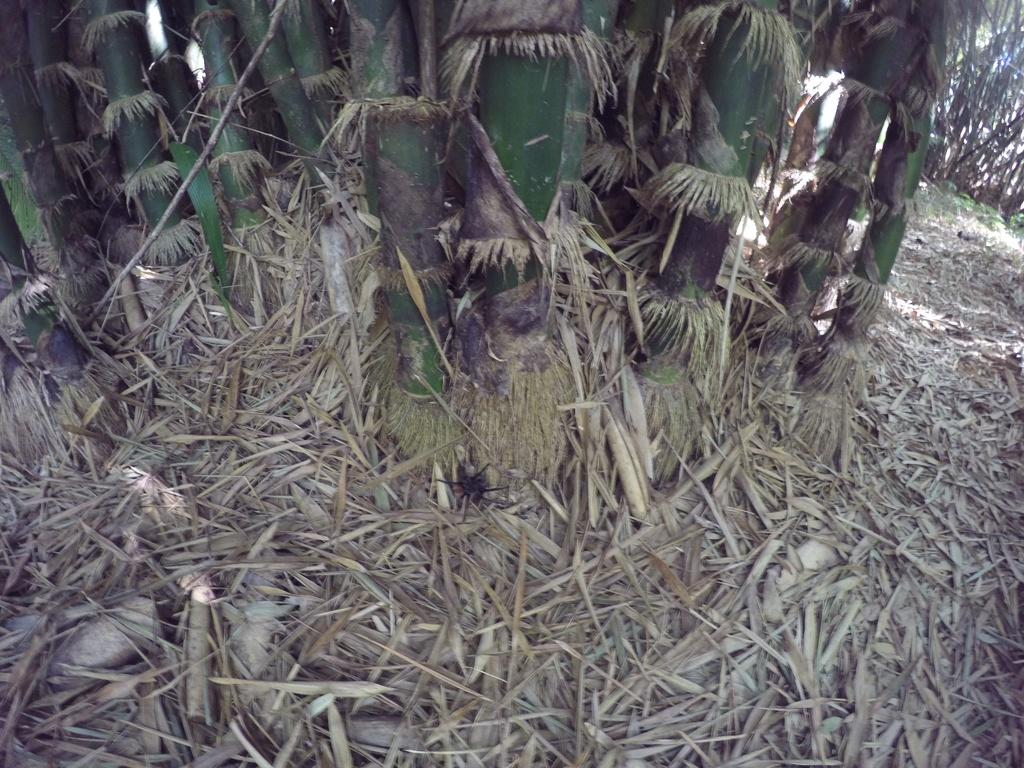What type of vegetation can be seen in the image? There are trees in the image. What is covering the ground in the image? Dry grass is present on the floor in the image. Where is the shelf located in the image? There is no shelf present in the image. What type of fiction can be seen in the image? There is no fiction present in the image; it features trees and dry grass. 